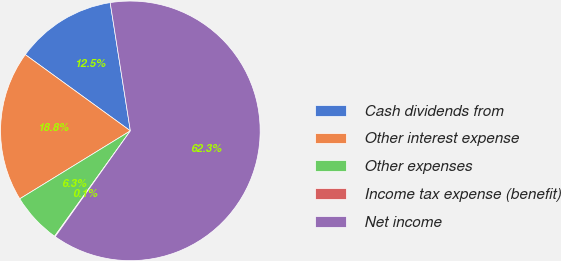Convert chart. <chart><loc_0><loc_0><loc_500><loc_500><pie_chart><fcel>Cash dividends from<fcel>Other interest expense<fcel>Other expenses<fcel>Income tax expense (benefit)<fcel>Net income<nl><fcel>12.53%<fcel>18.76%<fcel>6.31%<fcel>0.09%<fcel>62.32%<nl></chart> 